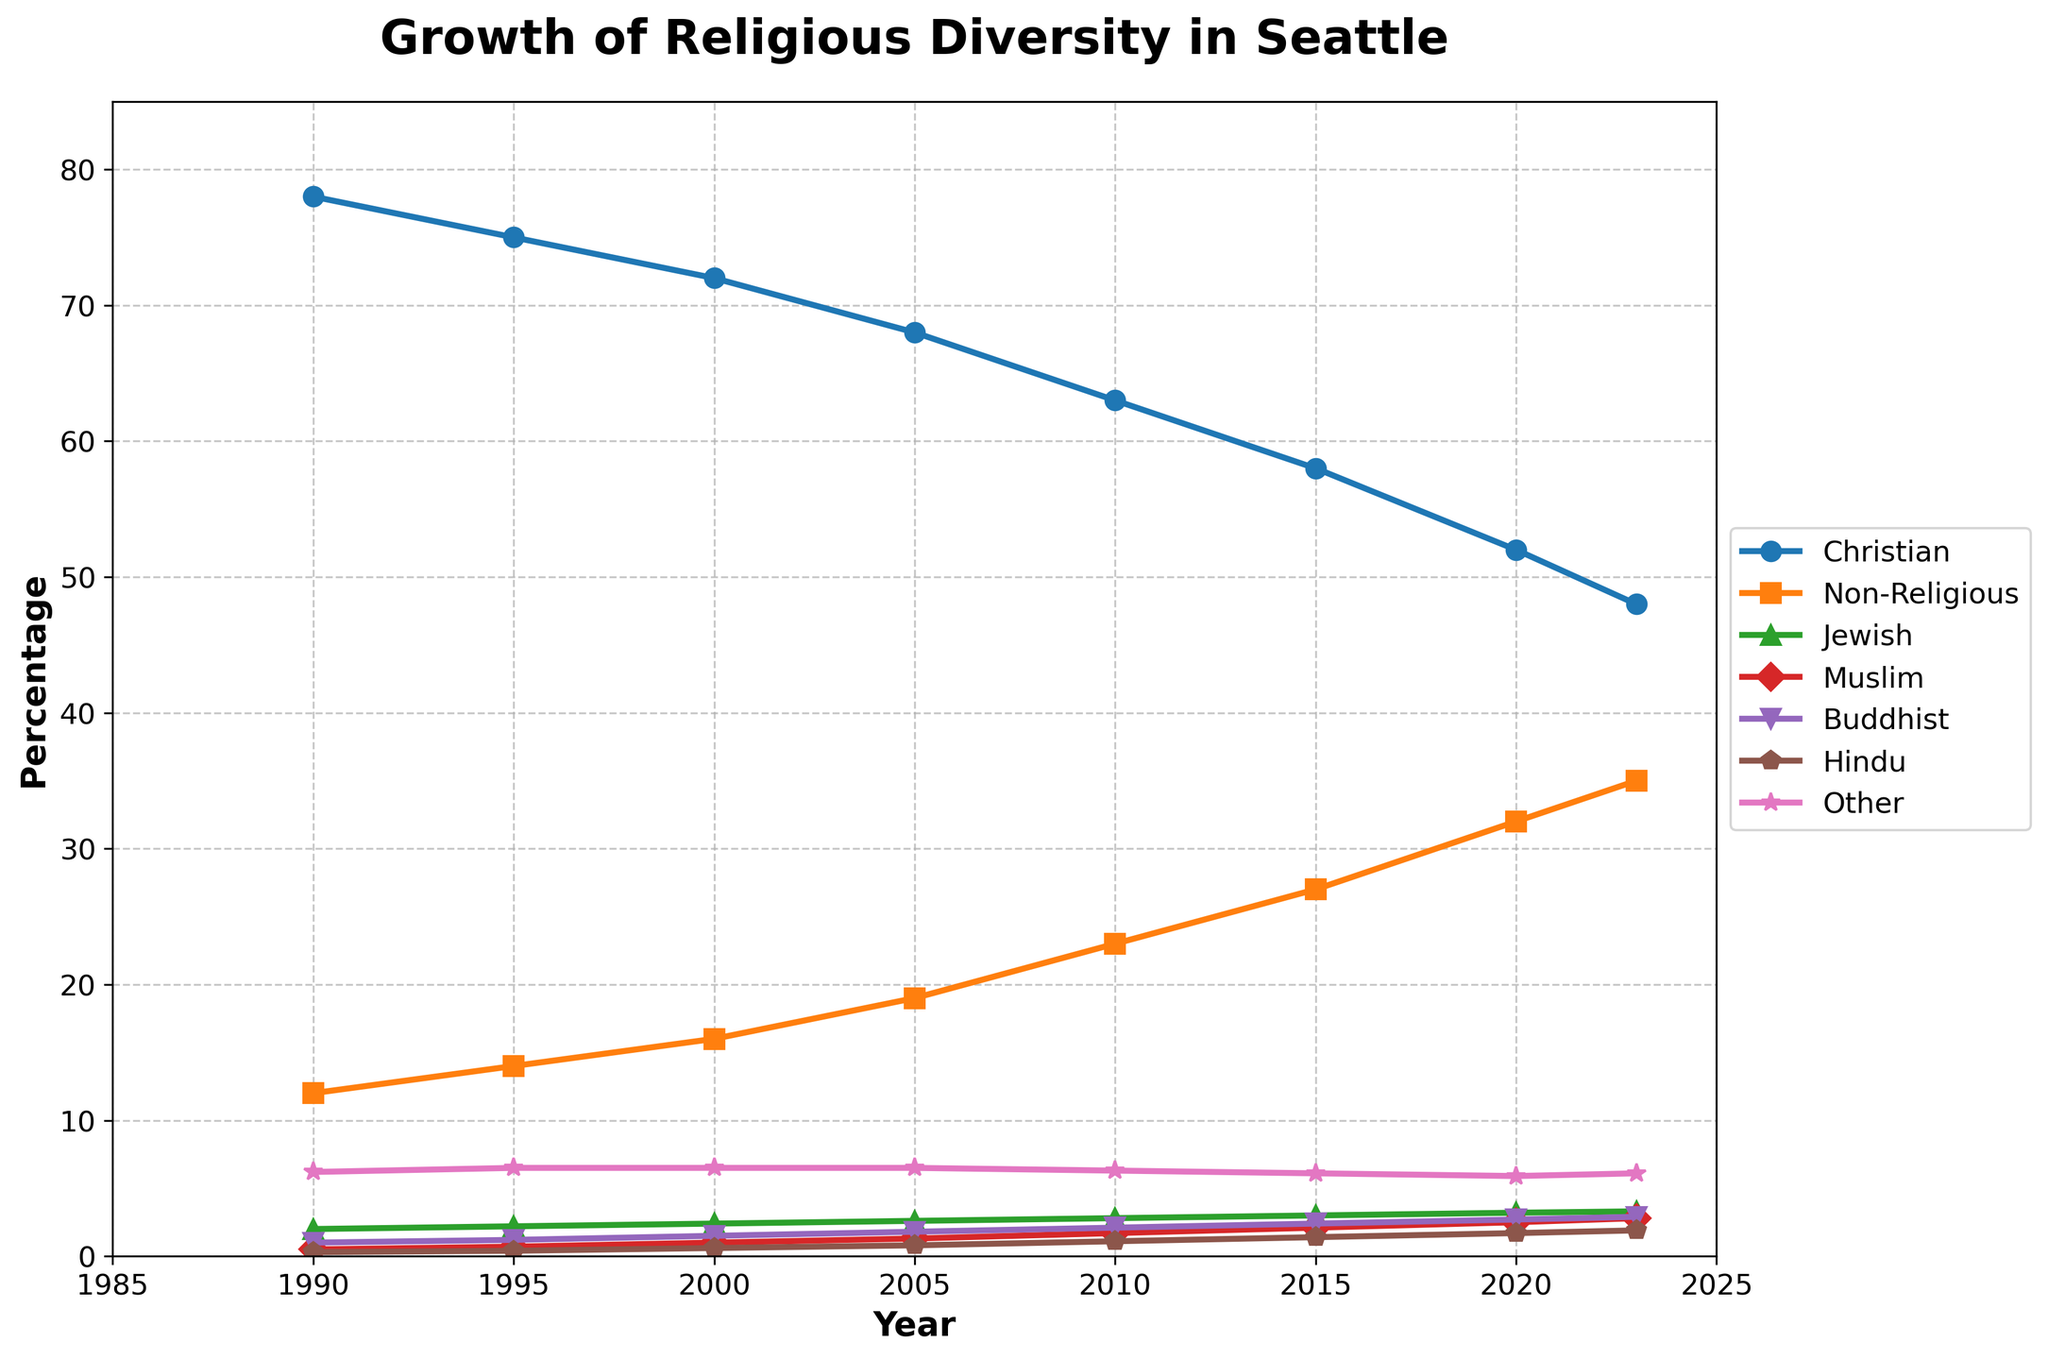What is the percentage increase in the Non-Religious group from 1990 to 2023? The Non-Religious percentage in 1990 is 12%. In 2023, it is 35%. The increase is 35% - 12% = 23%.
Answer: 23% Which group saw the largest percentage decrease from 1990 to 2023? Comparing the group percentages from 1990 to 2023, Christians decreased from 78% to 48%, the largest decrease among all groups, which is 78% - 48% = 30%.
Answer: Christians What is the difference in the percentage of Jewish people between 2000 and 2020? In 2000, the percentage of Jewish people is 2.4%. In 2020, it is 3.2%. The difference is 3.2% - 2.4% = 0.8%.
Answer: 0.8% Which faiths have percentages that increased consistently from 1990 to 2023? By examining the line trends, the percentages for Non-Religious, Muslim, Buddhist, and Hindu groups consistently increase over the years from 1990 to 2023.
Answer: Non-Religious, Muslim, Buddhist, Hindu What is the average percentage of the Buddhist group over the years listed? The Buddhist percentages over the years are: 1% (1990), 1.2% (1995), 1.5% (2000), 1.8% (2005), 2.1% (2010), 2.4% (2015), 2.7% (2020), 2.9% (2023). The average is (1 + 1.2 + 1.5 + 1.8 + 2.1 + 2.4 + 2.7 + 2.9) / 8 = 15.6 / 8 = 1.95%.
Answer: 1.95% In which year did the Christian percentage first fall below 70%? The Christian percentage falls below 70% in 2005 when it is 68%.
Answer: 2005 What is the combined percentage of Jewish, Muslim, Buddhist, and Hindu groups in 2023? In 2023, the percentages are: Jewish 3.3%, Muslim 2.8%, Buddhist 2.9%, Hindu 1.9%. Combined, it is 3.3% + 2.8% + 2.9% + 1.9% = 10.9%.
Answer: 10.9% Which group had the smallest percentage change from 1990 to 2023? Comparing the changes, Other changed from 6.2% in 1990 to 6.1% in 2023, a 0.1% decrease, which is the smallest percentage change among all groups.
Answer: Other What trend do you observe in the Non-Religious group over the years? The Non-Religious group shows a consistent increasing trend from 12% in 1990 to 35% in 2023, indicating a continuous rise in percentage over time.
Answer: Increasing trend In what year did the Non-Religious group surpass the 25% mark? According to the trend, the Non-Religious group surpasses the 25% mark in 2015, when it reaches 27%.
Answer: 2015 